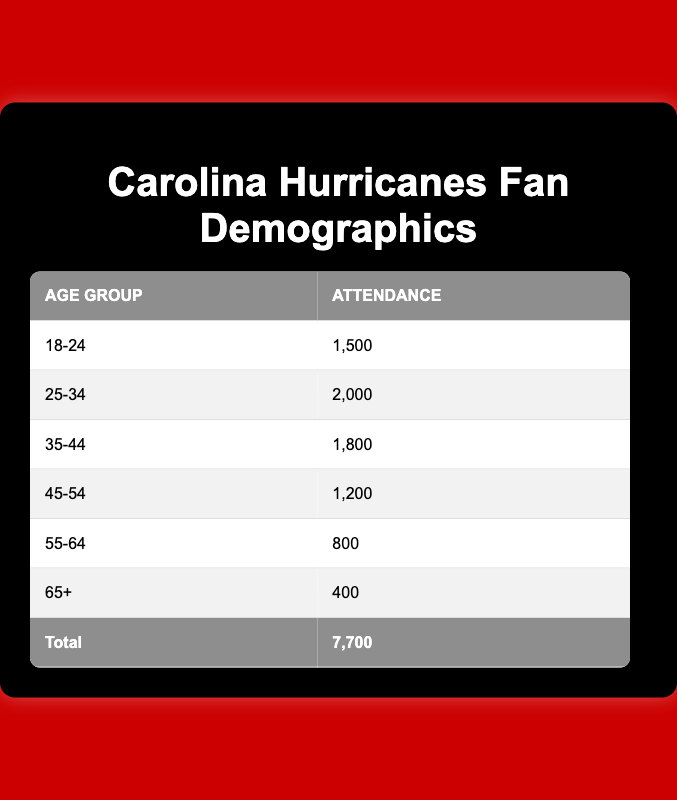What is the age group with the highest attendance? By examining the attendance values for each age group, we see that the highest attendance value is 2000, which corresponds to the age group 25-34.
Answer: 25-34 What is the total attendance at Carolina Hurricanes games based on the table? To calculate the total attendance, we sum all the attendance values: 1500 + 2000 + 1800 + 1200 + 800 + 400 = 7700.
Answer: 7700 What percentage of the total attendance does the age group 45-54 represent? The attendance for the age group 45-54 is 1200. To find the percentage, we would use the formula (1200/7700) * 100, which results in approximately 15.58%.
Answer: 15.58% Is the attendance for the age group 65+ more than the total attendance for the age group 55-64? The attendance for 65+ is 400 and for 55-64 is 800. Since 400 is less than 800, the statement is false.
Answer: No Which age group has the least attendance, and what is that attendance? By looking at the table, the age group with the least attendance is 65+, which has an attendance of 400.
Answer: 65+, 400 What is the difference in attendance between the age groups 25-34 and 55-64? The attendance for 25-34 is 2000 and for 55-64 is 800. The difference is calculated as 2000 - 800 = 1200.
Answer: 1200 If we combine the attendance numbers for age groups 18-24 and 35-44, what is the total? Adding the attendance of 18-24 (1500) and 35-44 (1800) together gives us 1500 + 1800 = 3300.
Answer: 3300 How many age groups have attendance figures fewer than 1000? There are two age groups with attendance fewer than 1000: 55-64 (800) and 65+ (400). Therefore, the count is 2.
Answer: 2 